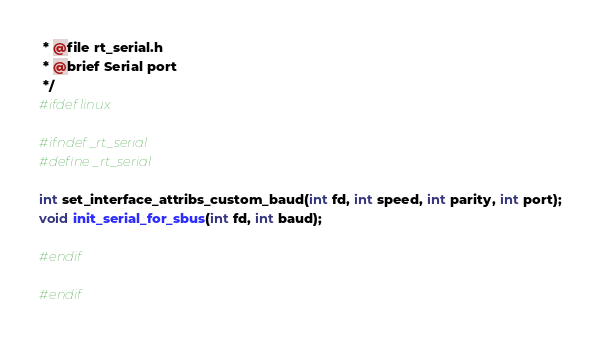<code> <loc_0><loc_0><loc_500><loc_500><_C_> * @file rt_serial.h
 * @brief Serial port
 */
#ifdef linux

#ifndef _rt_serial
#define _rt_serial

int set_interface_attribs_custom_baud(int fd, int speed, int parity, int port);
void init_serial_for_sbus(int fd, int baud);

#endif

#endif</code> 